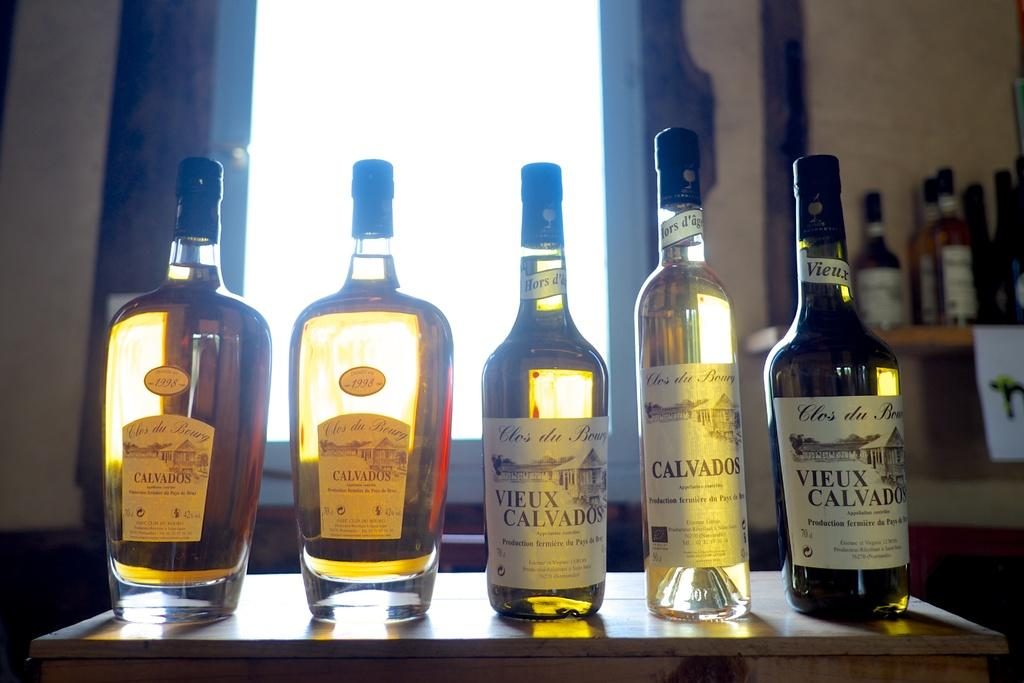<image>
Describe the image concisely. Several bottles bear the name Calvados on their labels. 